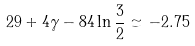Convert formula to latex. <formula><loc_0><loc_0><loc_500><loc_500>2 9 + 4 \gamma - 8 4 \ln \frac { 3 } { 2 } \simeq - 2 . 7 5</formula> 